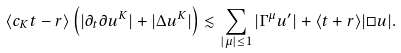<formula> <loc_0><loc_0><loc_500><loc_500>\langle c _ { K } t - r \rangle \left ( | \partial _ { t } \partial u ^ { K } | + | \Delta u ^ { K } | \right ) \lesssim \sum _ { | \mu | \leq 1 } | \Gamma ^ { \mu } u ^ { \prime } | + \langle t + r \rangle | \Box u | .</formula> 